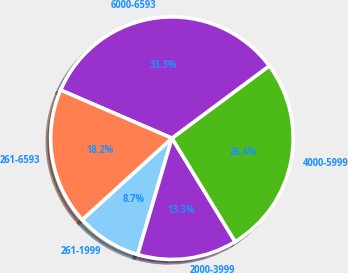Convert chart to OTSL. <chart><loc_0><loc_0><loc_500><loc_500><pie_chart><fcel>261-1999<fcel>2000-3999<fcel>4000-5999<fcel>6000-6593<fcel>261-6593<nl><fcel>8.7%<fcel>13.28%<fcel>26.44%<fcel>33.34%<fcel>18.24%<nl></chart> 